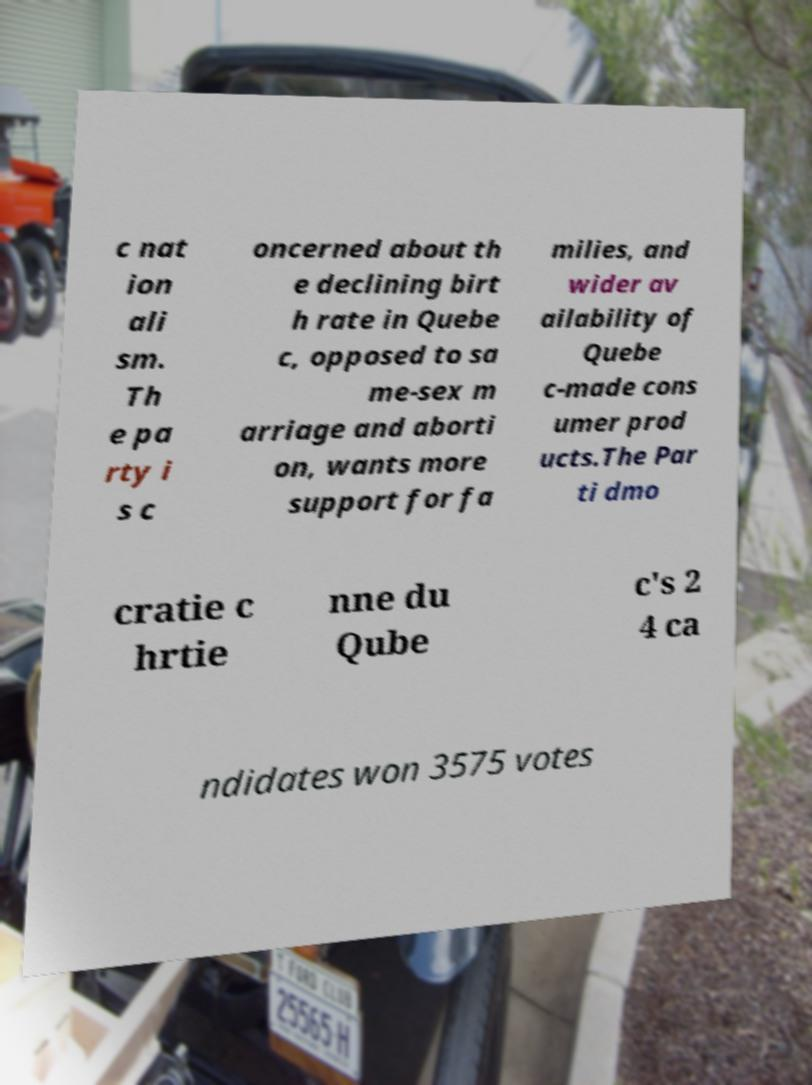What messages or text are displayed in this image? I need them in a readable, typed format. c nat ion ali sm. Th e pa rty i s c oncerned about th e declining birt h rate in Quebe c, opposed to sa me-sex m arriage and aborti on, wants more support for fa milies, and wider av ailability of Quebe c-made cons umer prod ucts.The Par ti dmo cratie c hrtie nne du Qube c's 2 4 ca ndidates won 3575 votes 